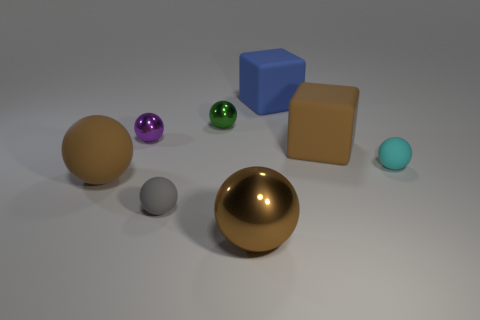Describe the lighting and shadows in the scene. What can we infer about the light source? The lighting in the scene appears to be coming from the upper right direction, casting soft-edged shadows towards the lower left. The softness of the shadows suggests the light source might be diffused or not narrowly focused. The highlighting on the objects, particularly the shiny ones, indicates a strong but possibly not direct light source. 